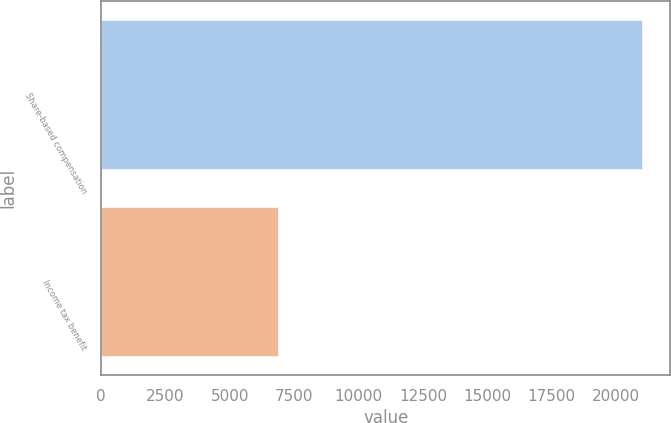<chart> <loc_0><loc_0><loc_500><loc_500><bar_chart><fcel>Share-based compensation<fcel>Income tax benefit<nl><fcel>21056<fcel>6907<nl></chart> 